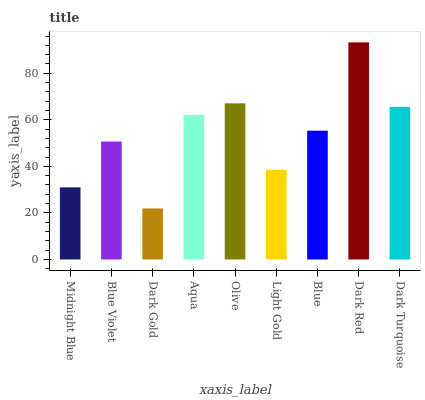Is Blue Violet the minimum?
Answer yes or no. No. Is Blue Violet the maximum?
Answer yes or no. No. Is Blue Violet greater than Midnight Blue?
Answer yes or no. Yes. Is Midnight Blue less than Blue Violet?
Answer yes or no. Yes. Is Midnight Blue greater than Blue Violet?
Answer yes or no. No. Is Blue Violet less than Midnight Blue?
Answer yes or no. No. Is Blue the high median?
Answer yes or no. Yes. Is Blue the low median?
Answer yes or no. Yes. Is Olive the high median?
Answer yes or no. No. Is Blue Violet the low median?
Answer yes or no. No. 